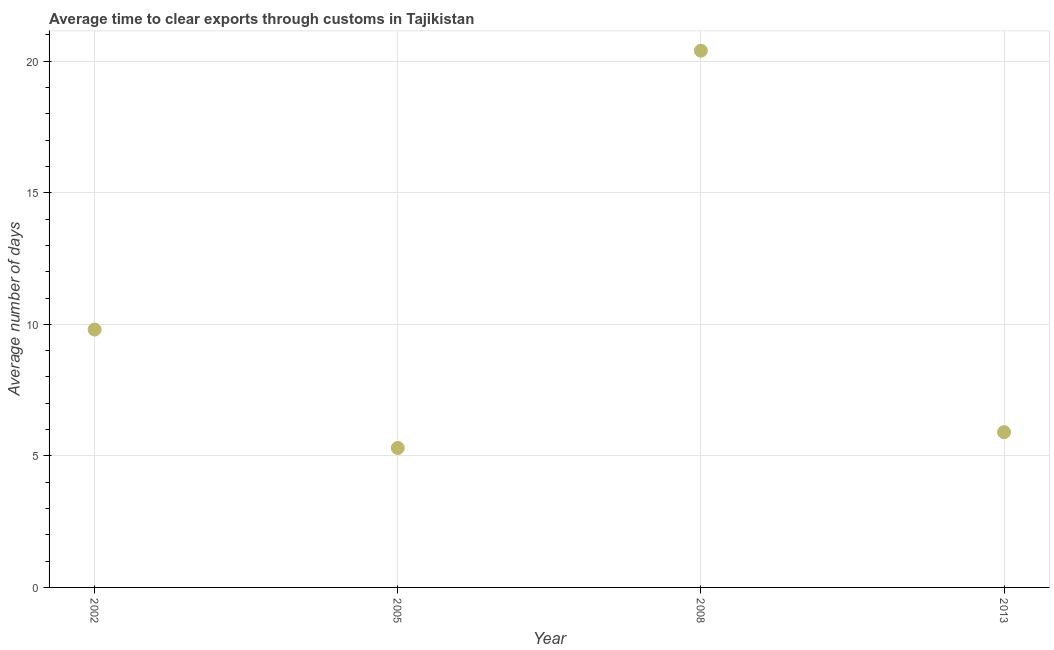What is the time to clear exports through customs in 2013?
Your response must be concise. 5.9. Across all years, what is the maximum time to clear exports through customs?
Ensure brevity in your answer.  20.4. In which year was the time to clear exports through customs maximum?
Your response must be concise. 2008. What is the sum of the time to clear exports through customs?
Offer a terse response. 41.4. What is the difference between the time to clear exports through customs in 2002 and 2005?
Your answer should be compact. 4.5. What is the average time to clear exports through customs per year?
Offer a very short reply. 10.35. What is the median time to clear exports through customs?
Your answer should be very brief. 7.85. Do a majority of the years between 2013 and 2008 (inclusive) have time to clear exports through customs greater than 9 days?
Make the answer very short. No. What is the ratio of the time to clear exports through customs in 2005 to that in 2013?
Your answer should be very brief. 0.9. What is the difference between the highest and the second highest time to clear exports through customs?
Keep it short and to the point. 10.6. Is the sum of the time to clear exports through customs in 2005 and 2008 greater than the maximum time to clear exports through customs across all years?
Ensure brevity in your answer.  Yes. What is the difference between the highest and the lowest time to clear exports through customs?
Ensure brevity in your answer.  15.1. How many dotlines are there?
Make the answer very short. 1. How many years are there in the graph?
Offer a terse response. 4. Are the values on the major ticks of Y-axis written in scientific E-notation?
Offer a very short reply. No. Does the graph contain grids?
Give a very brief answer. Yes. What is the title of the graph?
Give a very brief answer. Average time to clear exports through customs in Tajikistan. What is the label or title of the X-axis?
Your response must be concise. Year. What is the label or title of the Y-axis?
Provide a short and direct response. Average number of days. What is the Average number of days in 2005?
Your answer should be very brief. 5.3. What is the Average number of days in 2008?
Your response must be concise. 20.4. What is the Average number of days in 2013?
Keep it short and to the point. 5.9. What is the difference between the Average number of days in 2005 and 2008?
Your answer should be compact. -15.1. What is the ratio of the Average number of days in 2002 to that in 2005?
Provide a short and direct response. 1.85. What is the ratio of the Average number of days in 2002 to that in 2008?
Provide a short and direct response. 0.48. What is the ratio of the Average number of days in 2002 to that in 2013?
Keep it short and to the point. 1.66. What is the ratio of the Average number of days in 2005 to that in 2008?
Ensure brevity in your answer.  0.26. What is the ratio of the Average number of days in 2005 to that in 2013?
Ensure brevity in your answer.  0.9. What is the ratio of the Average number of days in 2008 to that in 2013?
Your answer should be very brief. 3.46. 